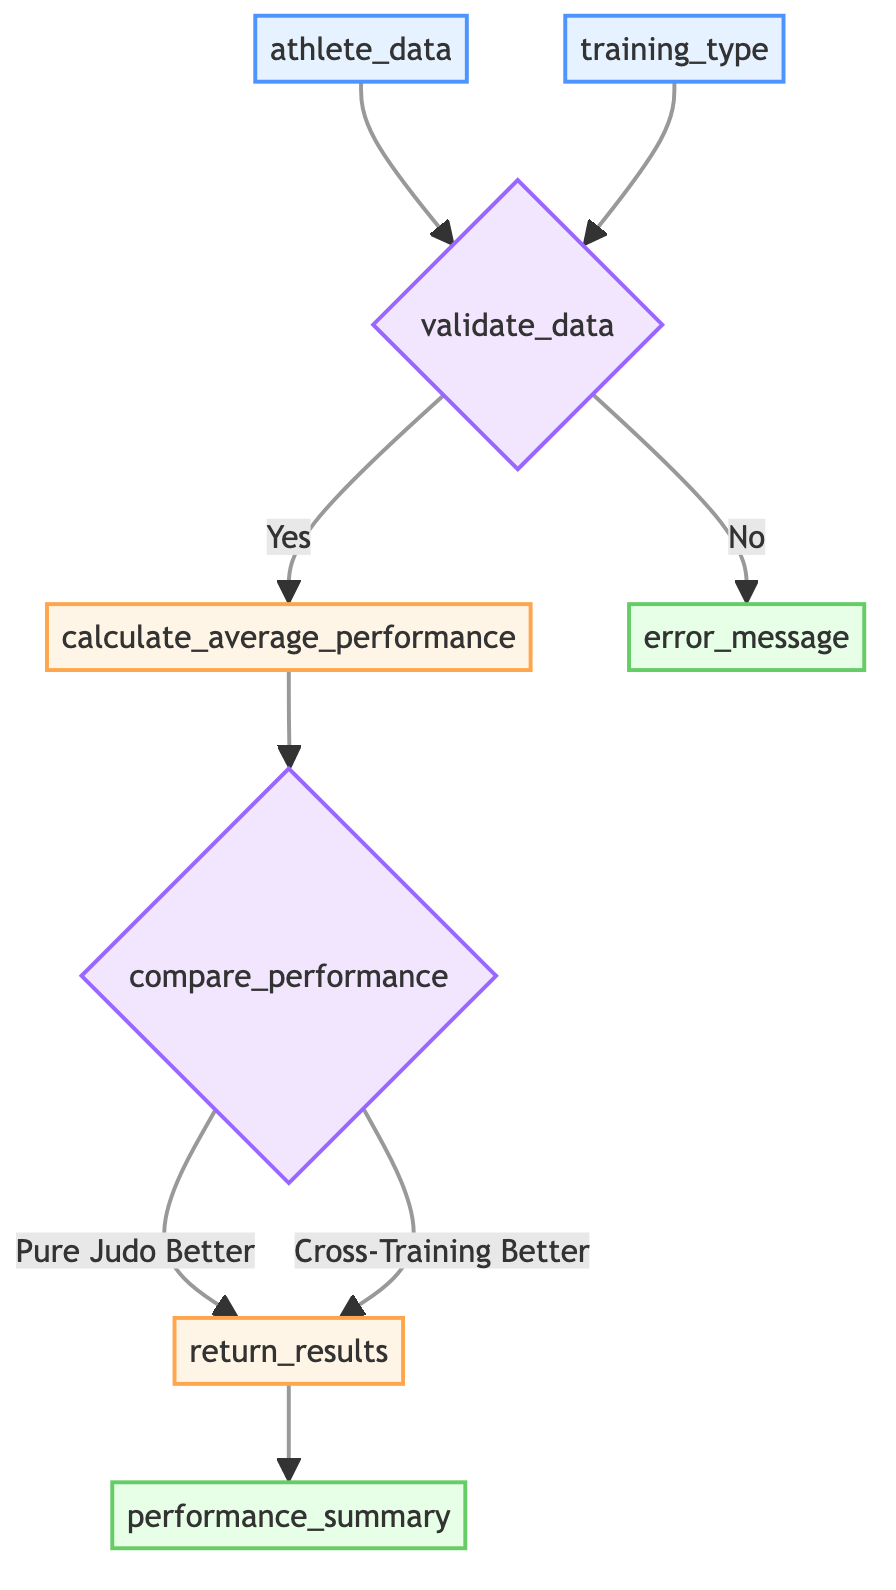What is the first input element in the flowchart? The first input element is labeled "athlete_data". This is indicated in the diagram where the node A represents the input for individual performance metrics.
Answer: athlete_data What type of data does "training_type" accept? The "training_type" input accepts a string data type, as shown in the description of node B. This indicates it can hold textual values referring to training methods.
Answer: string What happens if data validation fails? If data validation fails, the flowchart shows that an error message is returned, which corresponds to the output node labeled "error_message". Thus, the process will exit before analysis occurs.
Answer: return_error_message How many decision nodes are present in the diagram? The diagram contains two decision nodes; one for data validation and another for comparing performance. Each decision node dictates a significant decision point in the flowchart.
Answer: 2 What is calculated after data validation? After successful data validation, the flowchart shows that the "calculate_average_performance" process is executed. This step is crucial for determining the average metrics before any performance comparison.
Answer: average performance metrics What are the two possible outcomes of the performance comparison? The outcomes of the performance comparison are either "Pure Judo Better" or "Cross-Training Better". These paths represent the conclusion reached based on the average performance metrics calculated earlier.
Answer: Pure Judo Better or Cross-Training Better Which output summarizes the performance analysis? The output that summarizes the performance analysis is labeled "performance_summary". This output will convey the detailed results of the comparative analysis conducted in previous steps.
Answer: performance_summary What node comes after comparing performance? The node that comes after comparing performance is the "return_results" process. This node compiles the findings of the comparison and prepares them for output.
Answer: return_results 